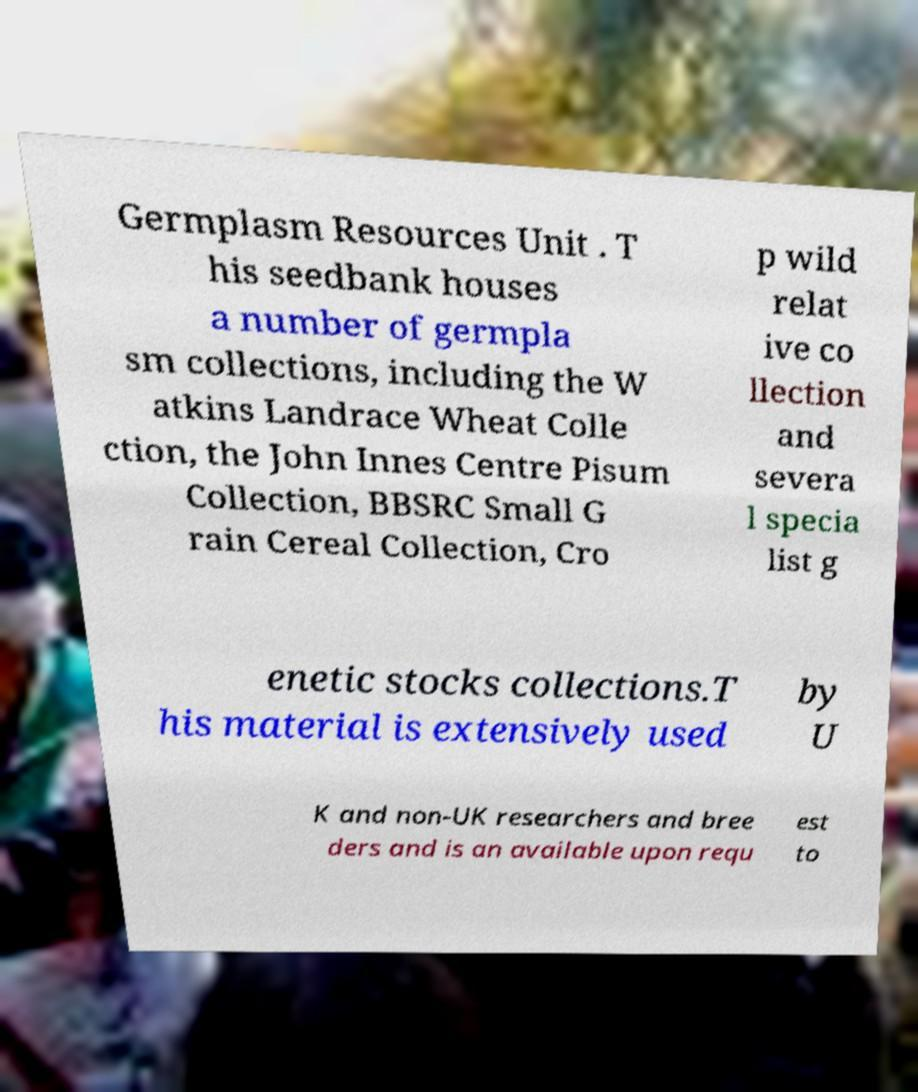Please read and relay the text visible in this image. What does it say? Germplasm Resources Unit . T his seedbank houses a number of germpla sm collections, including the W atkins Landrace Wheat Colle ction, the John Innes Centre Pisum Collection, BBSRC Small G rain Cereal Collection, Cro p wild relat ive co llection and severa l specia list g enetic stocks collections.T his material is extensively used by U K and non-UK researchers and bree ders and is an available upon requ est to 